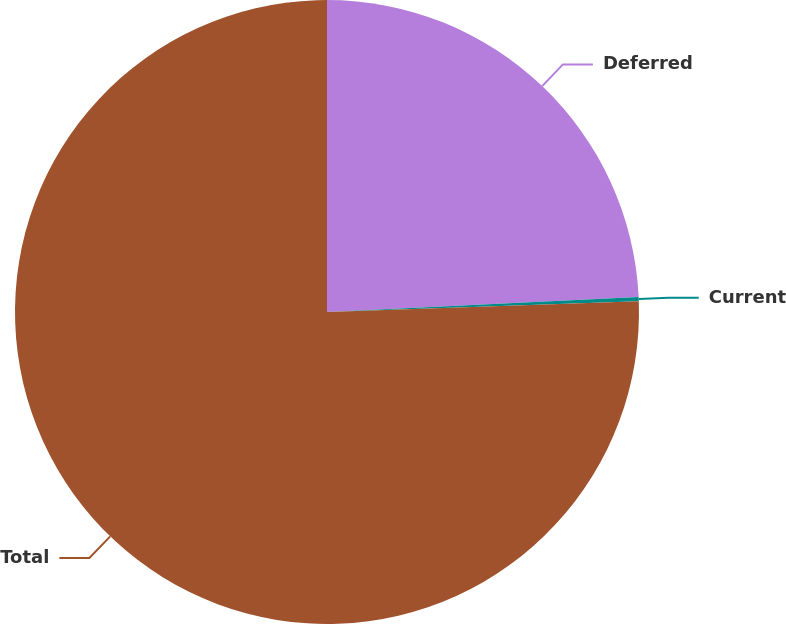<chart> <loc_0><loc_0><loc_500><loc_500><pie_chart><fcel>Deferred<fcel>Current<fcel>Total<nl><fcel>24.23%<fcel>0.22%<fcel>75.55%<nl></chart> 